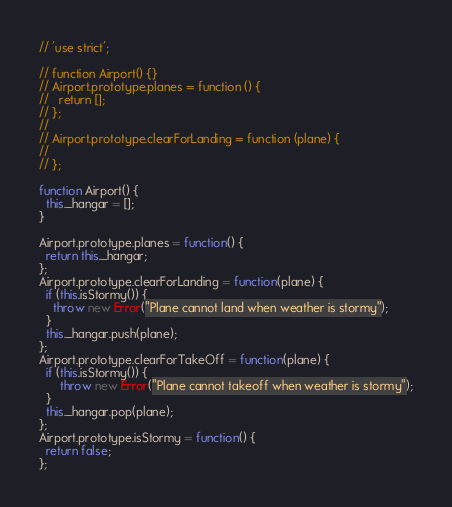<code> <loc_0><loc_0><loc_500><loc_500><_JavaScript_>// 'use strict';

// function Airport() {}
// Airport.prototype.planes = function () {
//   return [];
// };
//
// Airport.prototype.clearForLanding = function (plane) {
//
// };

function Airport() {
  this._hangar = [];
}

Airport.prototype.planes = function() {
  return this._hangar;
};
Airport.prototype.clearForLanding = function(plane) {
  if (this.isStormy()) {
    throw new Error("Plane cannot land when weather is stormy");
  }
  this._hangar.push(plane);
};
Airport.prototype.clearForTakeOff = function(plane) {
  if (this.isStormy()) {
      throw new Error("Plane cannot takeoff when weather is stormy");
  }
  this._hangar.pop(plane);
};
Airport.prototype.isStormy = function() {
  return false;
};
</code> 